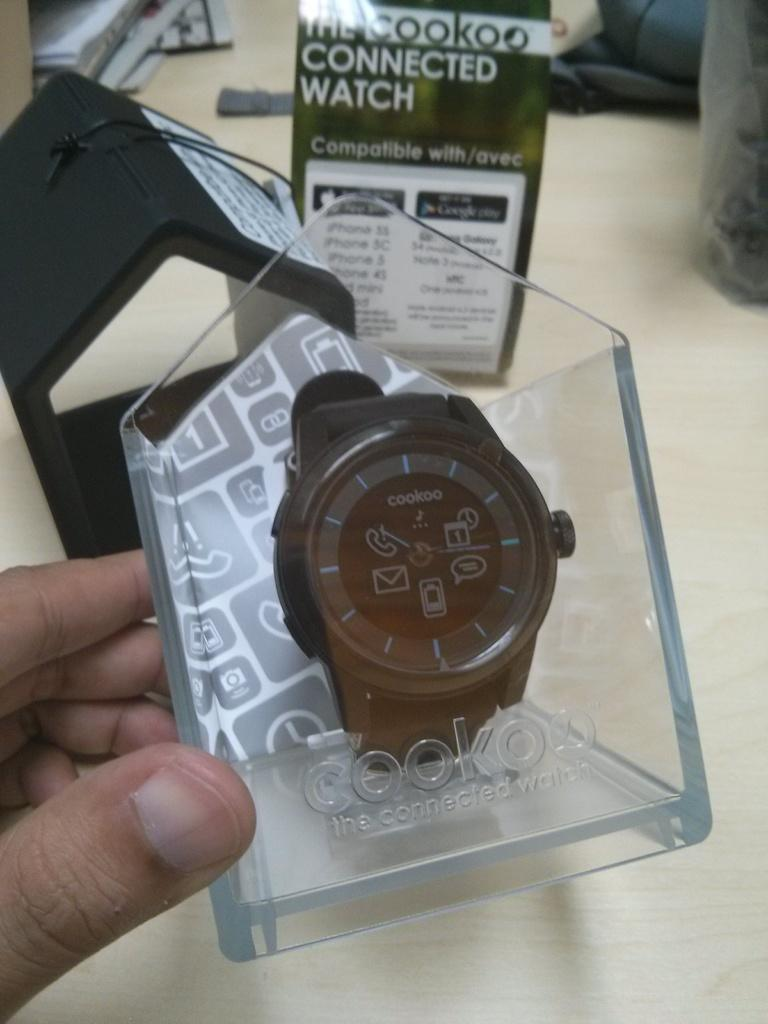<image>
Write a terse but informative summary of the picture. Metallic cookoo smart watch with winding knob on side, called "the connected watch". 